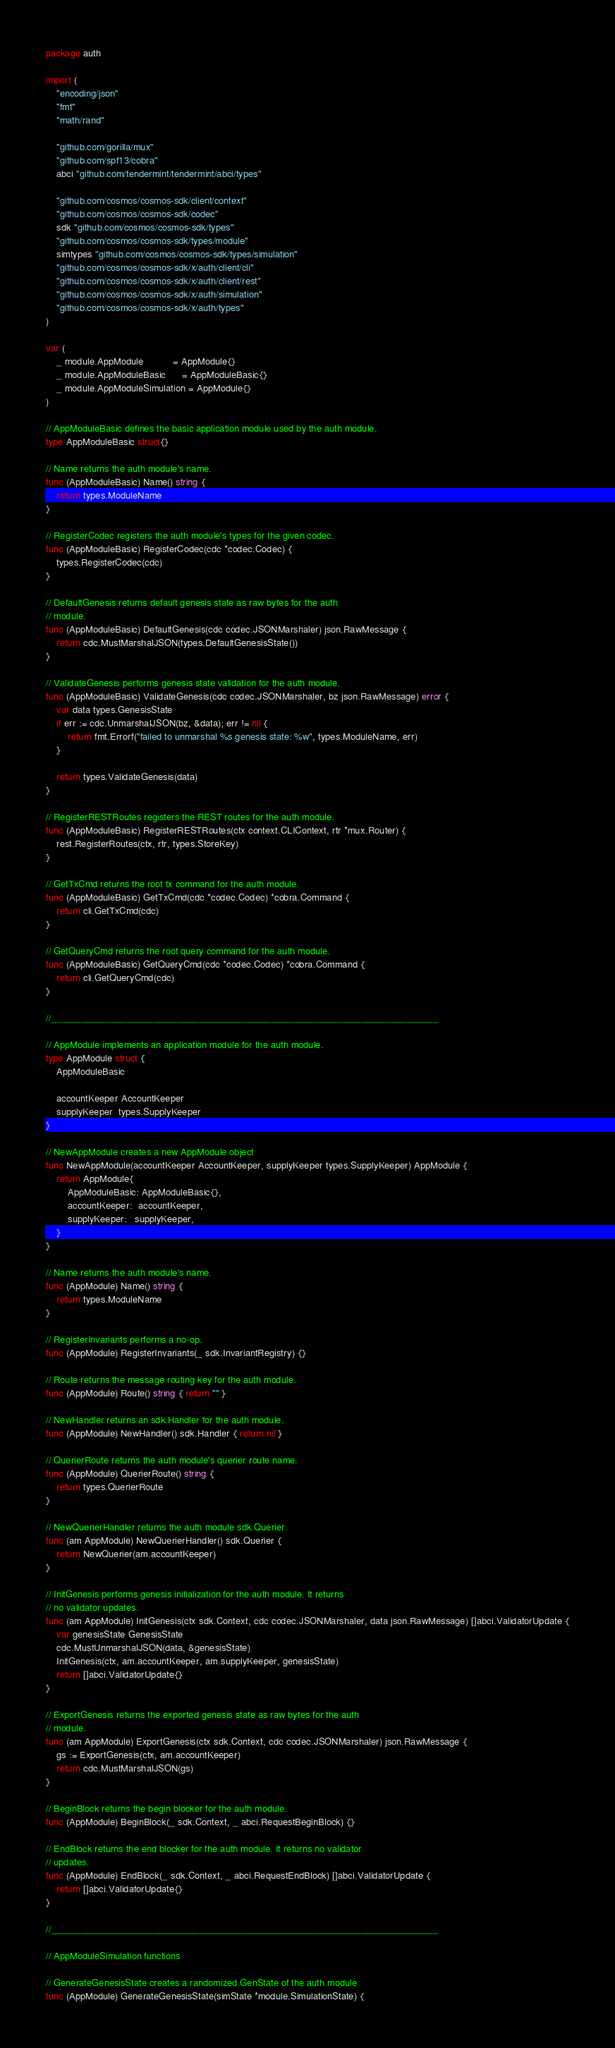Convert code to text. <code><loc_0><loc_0><loc_500><loc_500><_Go_>package auth

import (
	"encoding/json"
	"fmt"
	"math/rand"

	"github.com/gorilla/mux"
	"github.com/spf13/cobra"
	abci "github.com/tendermint/tendermint/abci/types"

	"github.com/cosmos/cosmos-sdk/client/context"
	"github.com/cosmos/cosmos-sdk/codec"
	sdk "github.com/cosmos/cosmos-sdk/types"
	"github.com/cosmos/cosmos-sdk/types/module"
	simtypes "github.com/cosmos/cosmos-sdk/types/simulation"
	"github.com/cosmos/cosmos-sdk/x/auth/client/cli"
	"github.com/cosmos/cosmos-sdk/x/auth/client/rest"
	"github.com/cosmos/cosmos-sdk/x/auth/simulation"
	"github.com/cosmos/cosmos-sdk/x/auth/types"
)

var (
	_ module.AppModule           = AppModule{}
	_ module.AppModuleBasic      = AppModuleBasic{}
	_ module.AppModuleSimulation = AppModule{}
)

// AppModuleBasic defines the basic application module used by the auth module.
type AppModuleBasic struct{}

// Name returns the auth module's name.
func (AppModuleBasic) Name() string {
	return types.ModuleName
}

// RegisterCodec registers the auth module's types for the given codec.
func (AppModuleBasic) RegisterCodec(cdc *codec.Codec) {
	types.RegisterCodec(cdc)
}

// DefaultGenesis returns default genesis state as raw bytes for the auth
// module.
func (AppModuleBasic) DefaultGenesis(cdc codec.JSONMarshaler) json.RawMessage {
	return cdc.MustMarshalJSON(types.DefaultGenesisState())
}

// ValidateGenesis performs genesis state validation for the auth module.
func (AppModuleBasic) ValidateGenesis(cdc codec.JSONMarshaler, bz json.RawMessage) error {
	var data types.GenesisState
	if err := cdc.UnmarshalJSON(bz, &data); err != nil {
		return fmt.Errorf("failed to unmarshal %s genesis state: %w", types.ModuleName, err)
	}

	return types.ValidateGenesis(data)
}

// RegisterRESTRoutes registers the REST routes for the auth module.
func (AppModuleBasic) RegisterRESTRoutes(ctx context.CLIContext, rtr *mux.Router) {
	rest.RegisterRoutes(ctx, rtr, types.StoreKey)
}

// GetTxCmd returns the root tx command for the auth module.
func (AppModuleBasic) GetTxCmd(cdc *codec.Codec) *cobra.Command {
	return cli.GetTxCmd(cdc)
}

// GetQueryCmd returns the root query command for the auth module.
func (AppModuleBasic) GetQueryCmd(cdc *codec.Codec) *cobra.Command {
	return cli.GetQueryCmd(cdc)
}

//____________________________________________________________________________

// AppModule implements an application module for the auth module.
type AppModule struct {
	AppModuleBasic

	accountKeeper AccountKeeper
	supplyKeeper  types.SupplyKeeper
}

// NewAppModule creates a new AppModule object
func NewAppModule(accountKeeper AccountKeeper, supplyKeeper types.SupplyKeeper) AppModule {
	return AppModule{
		AppModuleBasic: AppModuleBasic{},
		accountKeeper:  accountKeeper,
		supplyKeeper:   supplyKeeper,
	}
}

// Name returns the auth module's name.
func (AppModule) Name() string {
	return types.ModuleName
}

// RegisterInvariants performs a no-op.
func (AppModule) RegisterInvariants(_ sdk.InvariantRegistry) {}

// Route returns the message routing key for the auth module.
func (AppModule) Route() string { return "" }

// NewHandler returns an sdk.Handler for the auth module.
func (AppModule) NewHandler() sdk.Handler { return nil }

// QuerierRoute returns the auth module's querier route name.
func (AppModule) QuerierRoute() string {
	return types.QuerierRoute
}

// NewQuerierHandler returns the auth module sdk.Querier.
func (am AppModule) NewQuerierHandler() sdk.Querier {
	return NewQuerier(am.accountKeeper)
}

// InitGenesis performs genesis initialization for the auth module. It returns
// no validator updates.
func (am AppModule) InitGenesis(ctx sdk.Context, cdc codec.JSONMarshaler, data json.RawMessage) []abci.ValidatorUpdate {
	var genesisState GenesisState
	cdc.MustUnmarshalJSON(data, &genesisState)
	InitGenesis(ctx, am.accountKeeper, am.supplyKeeper, genesisState)
	return []abci.ValidatorUpdate{}
}

// ExportGenesis returns the exported genesis state as raw bytes for the auth
// module.
func (am AppModule) ExportGenesis(ctx sdk.Context, cdc codec.JSONMarshaler) json.RawMessage {
	gs := ExportGenesis(ctx, am.accountKeeper)
	return cdc.MustMarshalJSON(gs)
}

// BeginBlock returns the begin blocker for the auth module.
func (AppModule) BeginBlock(_ sdk.Context, _ abci.RequestBeginBlock) {}

// EndBlock returns the end blocker for the auth module. It returns no validator
// updates.
func (AppModule) EndBlock(_ sdk.Context, _ abci.RequestEndBlock) []abci.ValidatorUpdate {
	return []abci.ValidatorUpdate{}
}

//____________________________________________________________________________

// AppModuleSimulation functions

// GenerateGenesisState creates a randomized GenState of the auth module
func (AppModule) GenerateGenesisState(simState *module.SimulationState) {</code> 